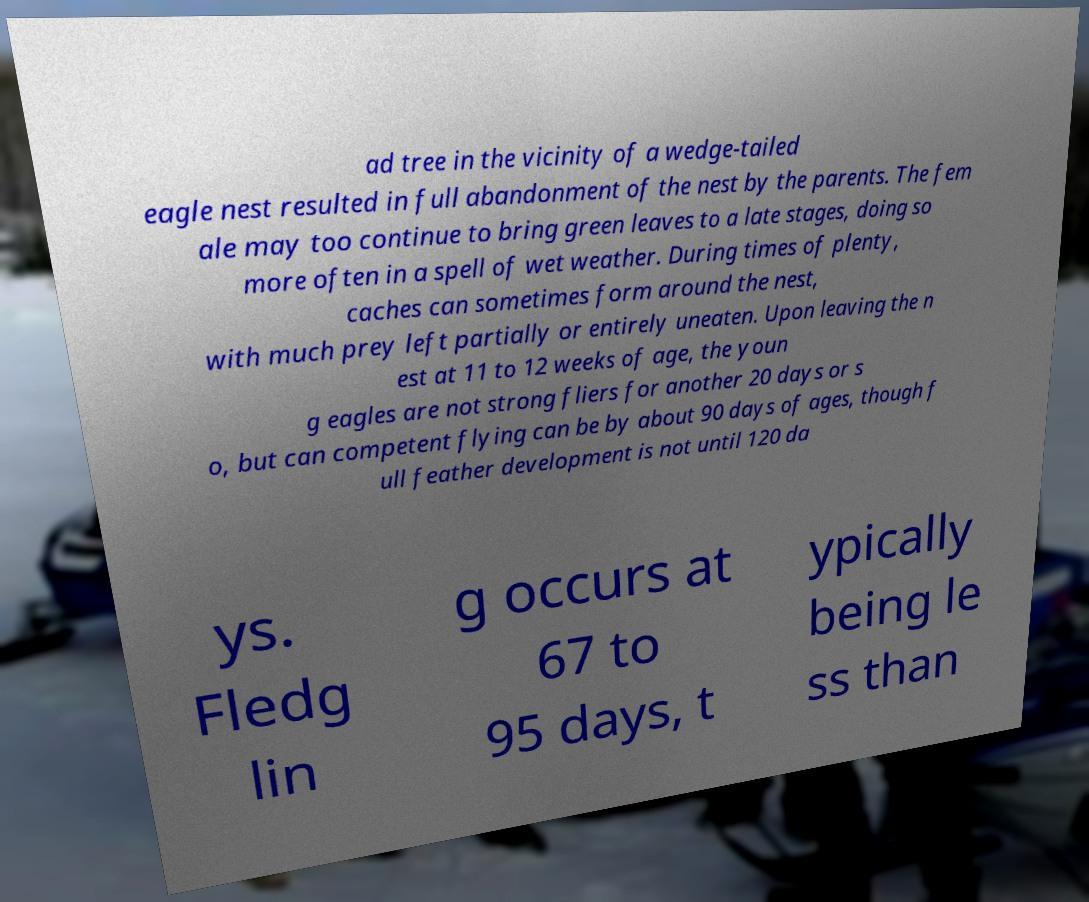Could you extract and type out the text from this image? ad tree in the vicinity of a wedge-tailed eagle nest resulted in full abandonment of the nest by the parents. The fem ale may too continue to bring green leaves to a late stages, doing so more often in a spell of wet weather. During times of plenty, caches can sometimes form around the nest, with much prey left partially or entirely uneaten. Upon leaving the n est at 11 to 12 weeks of age, the youn g eagles are not strong fliers for another 20 days or s o, but can competent flying can be by about 90 days of ages, though f ull feather development is not until 120 da ys. Fledg lin g occurs at 67 to 95 days, t ypically being le ss than 